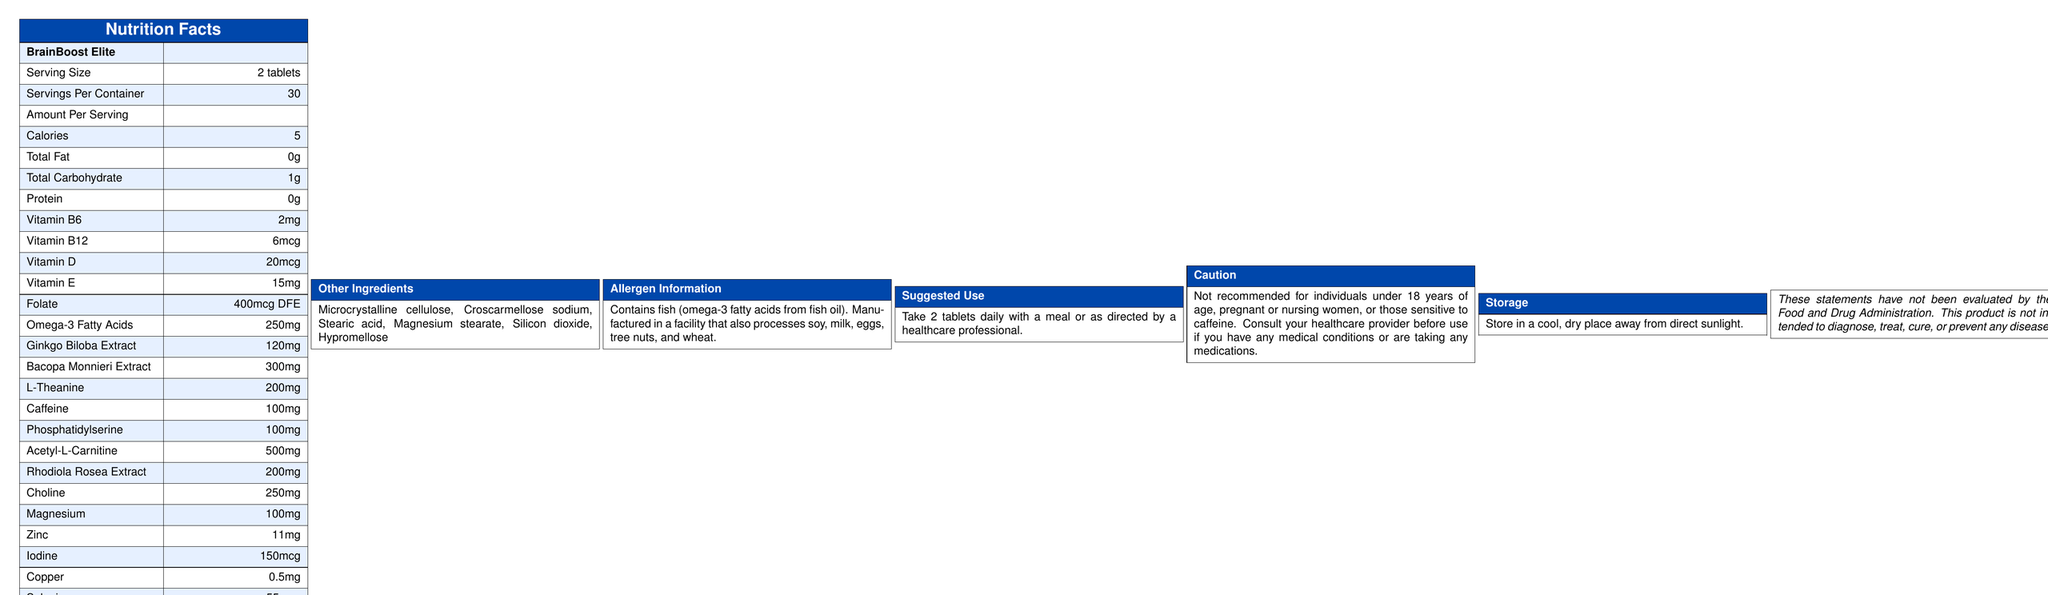what is the serving size for BrainBoost Elite? The serving size is explicitly stated under the Nutrition Facts section.
Answer: 2 tablets how many calories are in one serving of BrainBoost Elite? The document states that each serving provides 5 calories.
Answer: 5 calories how many servings are there per container of BrainBoost Elite? The number of servings per container is listed as 30 under the Nutrition Facts section.
Answer: 30 what is the amount of omega-3 fatty acids per serving? The amount of omega-3 fatty acids per serving is stated as 250mg in the document.
Answer: 250mg what is the amount of vitamin B12 per serving? The amount of vitamin B12 per serving is specified as 6mcg in the Nutrition Facts.
Answer: 6mcg which ingredient is present in the highest amount in BrainBoost Elite? A. L-Theanine B. Caffeine C. Acetyl-L-Carnitine D. Ginkgo Biloba Extract Acetyl-L-Carnitine is present at 500mg per serving, which is higher than the quantities of the other listed ingredients.
Answer: C which vitamin is not listed in the BrainBoost Elite supplement? A. Vitamin A B. Vitamin B6 C. Vitamin D D. Vitamin E Vitamin A is not mentioned in the list of vitamins contained in BrainBoost Elite.
Answer: A is BrainBoost Elite suitable for someone with a fish allergy? The allergen information contains a caution that it contains fish (omega-3 fatty acids from fish oil), indicating it is not suitable for someone with a fish allergy.
Answer: No who should avoid taking BrainBoost Elite? The caution section specifies these groups should avoid taking the supplement or consult a healthcare provider before use.
Answer: Individuals under 18 years of age, pregnant or nursing women, or those sensitive to caffeine what is the suggested use of BrainBoost Elite? The suggested use is explicitly stated in the document.
Answer: Take 2 tablets daily with a meal or as directed by a healthcare professional what should you do if you are sensitive to caffeine? The caution section advises consulting a healthcare provider for individuals sensitive to caffeine.
Answer: Consult your healthcare provider before use what are the other ingredients included in BrainBoost Elite? The other ingredients are listed under the "Other Ingredients" section.
Answer: Microcrystalline cellulose, Croscarmellose sodium, Stearic acid, Magnesium stearate, Silicon dioxide, Hypromellose how should BrainBoost Elite be stored? The storage instructions are provided in the document.
Answer: Store in a cool, dry place away from direct sunlight what does the supplement facts disclaimer state? The disclaimer is explicitly stated at the end of the document.
Answer: This product is not intended to diagnose, treat, cure, or prevent any disease. These statements have not been evaluated by the Food and Drug Administration. describe the main idea of the document. The document includes sections on serving size, quantities of various vitamins and substances, additional ingredients, allergen warnings, usage instructions, and FDA disclaimer.
Answer: It provides detailed Nutrition Facts, ingredients, suggested use, allergen information, caution, and storage instructions for a vitamin and mineral supplement named BrainBoost Elite, formulated to support cognitive function and mental alertness. how many grams of total fat are in one serving of BrainBoost Elite? The Nutrition Facts section states that there are 0 grams of total fat per serving.
Answer: 0g can you take BrainBoost Elite on an empty stomach? The document suggests taking 2 tablets daily with a meal or as directed by a healthcare professional, but does not specifically state whether it can be taken on an empty stomach.
Answer: Not specified 